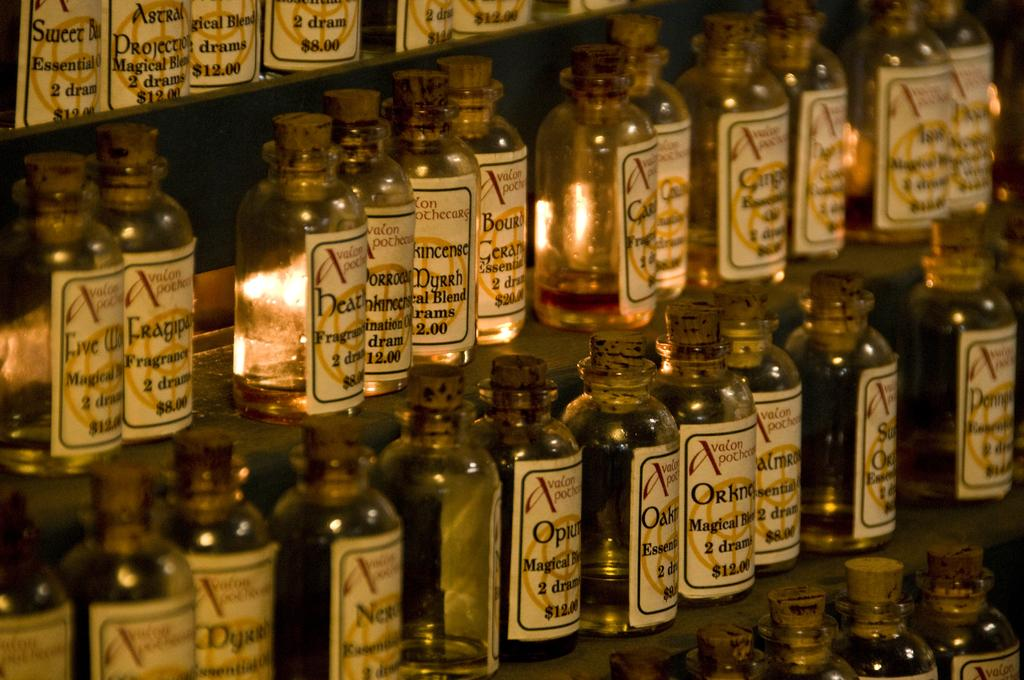<image>
Describe the image concisely. lots of bottles containing different products, the first at the top advertised sweet essential 